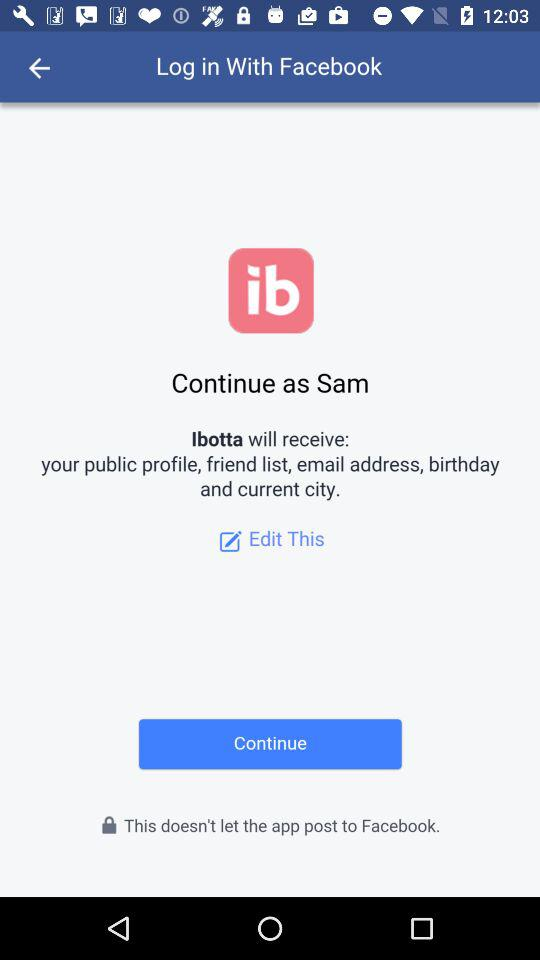Which email address will "Ibotta" receive?
When the provided information is insufficient, respond with <no answer>. <no answer> 